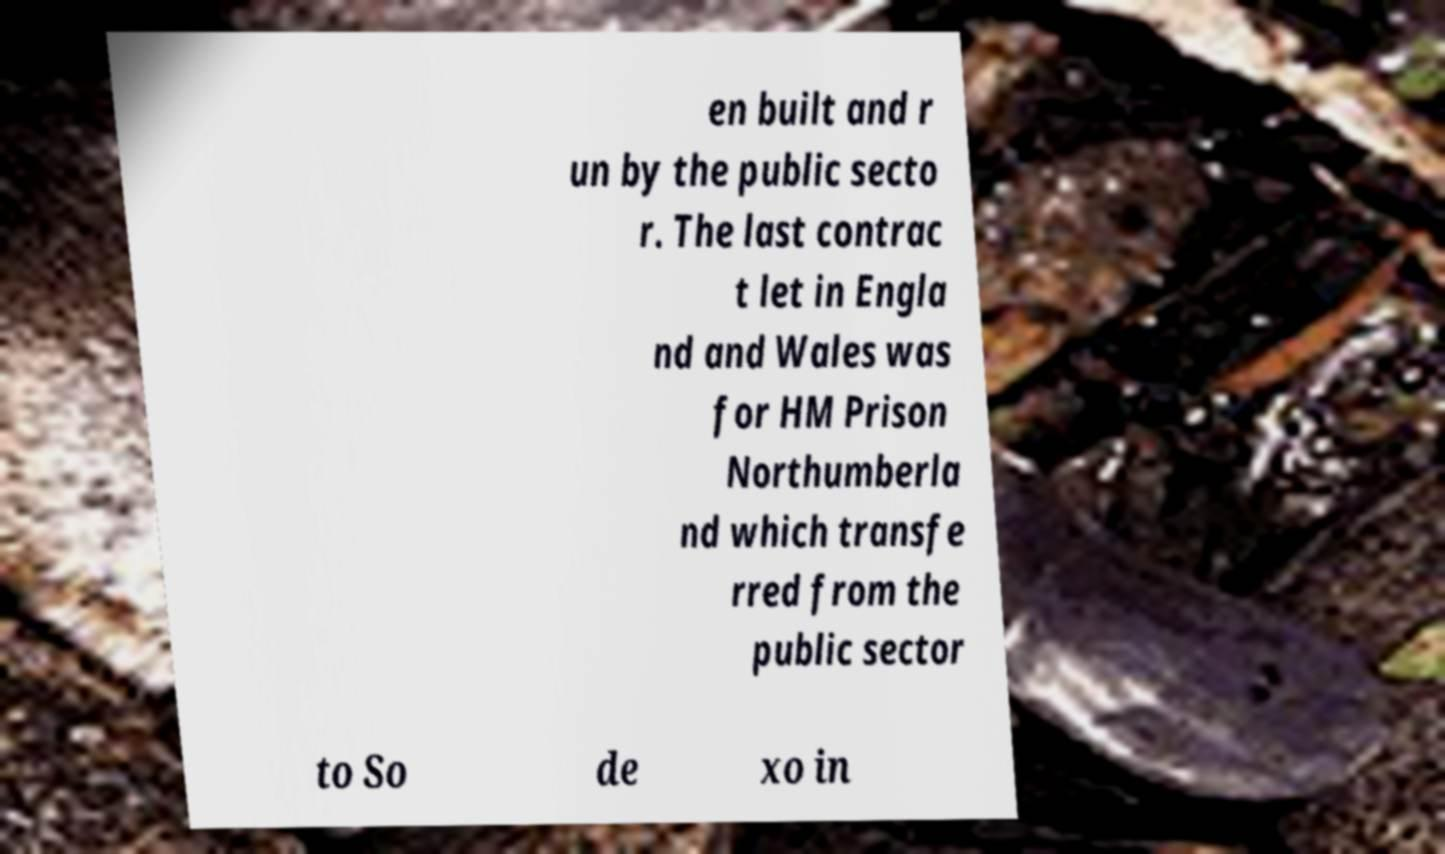Could you assist in decoding the text presented in this image and type it out clearly? en built and r un by the public secto r. The last contrac t let in Engla nd and Wales was for HM Prison Northumberla nd which transfe rred from the public sector to So de xo in 